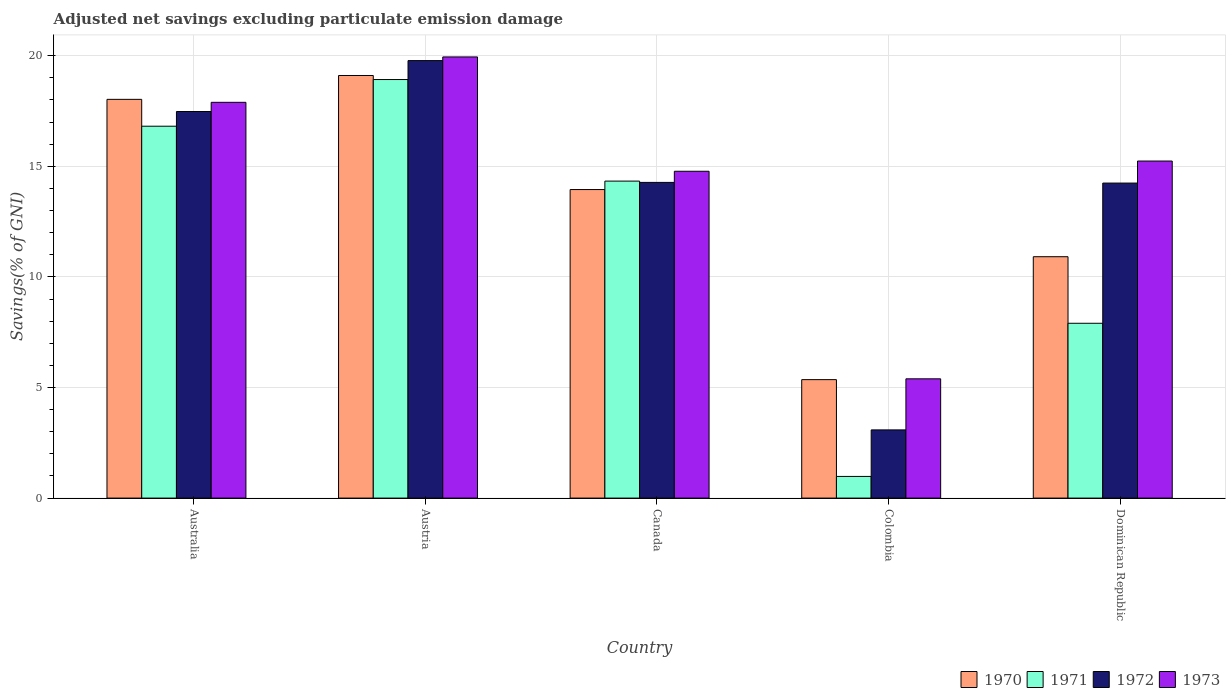How many different coloured bars are there?
Your answer should be compact. 4. How many groups of bars are there?
Give a very brief answer. 5. Are the number of bars on each tick of the X-axis equal?
Ensure brevity in your answer.  Yes. How many bars are there on the 3rd tick from the left?
Make the answer very short. 4. How many bars are there on the 5th tick from the right?
Your answer should be compact. 4. What is the label of the 2nd group of bars from the left?
Provide a succinct answer. Austria. What is the adjusted net savings in 1970 in Australia?
Make the answer very short. 18.03. Across all countries, what is the maximum adjusted net savings in 1973?
Make the answer very short. 19.94. Across all countries, what is the minimum adjusted net savings in 1971?
Offer a very short reply. 0.98. In which country was the adjusted net savings in 1972 maximum?
Keep it short and to the point. Austria. In which country was the adjusted net savings in 1971 minimum?
Keep it short and to the point. Colombia. What is the total adjusted net savings in 1972 in the graph?
Ensure brevity in your answer.  68.85. What is the difference between the adjusted net savings in 1972 in Colombia and that in Dominican Republic?
Provide a succinct answer. -11.16. What is the difference between the adjusted net savings in 1971 in Austria and the adjusted net savings in 1973 in Australia?
Your response must be concise. 1.03. What is the average adjusted net savings in 1972 per country?
Offer a terse response. 13.77. What is the difference between the adjusted net savings of/in 1970 and adjusted net savings of/in 1972 in Canada?
Provide a short and direct response. -0.32. What is the ratio of the adjusted net savings in 1970 in Australia to that in Canada?
Provide a succinct answer. 1.29. Is the adjusted net savings in 1970 in Australia less than that in Canada?
Make the answer very short. No. Is the difference between the adjusted net savings in 1970 in Austria and Colombia greater than the difference between the adjusted net savings in 1972 in Austria and Colombia?
Your answer should be compact. No. What is the difference between the highest and the second highest adjusted net savings in 1972?
Your answer should be very brief. -2.3. What is the difference between the highest and the lowest adjusted net savings in 1971?
Your answer should be very brief. 17.94. How many bars are there?
Your answer should be very brief. 20. Does the graph contain grids?
Make the answer very short. Yes. Where does the legend appear in the graph?
Your response must be concise. Bottom right. How many legend labels are there?
Your answer should be very brief. 4. How are the legend labels stacked?
Ensure brevity in your answer.  Horizontal. What is the title of the graph?
Give a very brief answer. Adjusted net savings excluding particulate emission damage. Does "1961" appear as one of the legend labels in the graph?
Provide a short and direct response. No. What is the label or title of the Y-axis?
Offer a terse response. Savings(% of GNI). What is the Savings(% of GNI) of 1970 in Australia?
Keep it short and to the point. 18.03. What is the Savings(% of GNI) in 1971 in Australia?
Offer a terse response. 16.81. What is the Savings(% of GNI) of 1972 in Australia?
Offer a terse response. 17.48. What is the Savings(% of GNI) in 1973 in Australia?
Give a very brief answer. 17.89. What is the Savings(% of GNI) of 1970 in Austria?
Give a very brief answer. 19.11. What is the Savings(% of GNI) of 1971 in Austria?
Ensure brevity in your answer.  18.92. What is the Savings(% of GNI) in 1972 in Austria?
Offer a terse response. 19.78. What is the Savings(% of GNI) of 1973 in Austria?
Offer a very short reply. 19.94. What is the Savings(% of GNI) in 1970 in Canada?
Offer a terse response. 13.95. What is the Savings(% of GNI) of 1971 in Canada?
Your response must be concise. 14.33. What is the Savings(% of GNI) in 1972 in Canada?
Provide a short and direct response. 14.27. What is the Savings(% of GNI) in 1973 in Canada?
Provide a short and direct response. 14.78. What is the Savings(% of GNI) of 1970 in Colombia?
Make the answer very short. 5.36. What is the Savings(% of GNI) of 1971 in Colombia?
Your answer should be compact. 0.98. What is the Savings(% of GNI) in 1972 in Colombia?
Offer a very short reply. 3.08. What is the Savings(% of GNI) of 1973 in Colombia?
Your answer should be very brief. 5.39. What is the Savings(% of GNI) in 1970 in Dominican Republic?
Offer a very short reply. 10.91. What is the Savings(% of GNI) of 1971 in Dominican Republic?
Your answer should be very brief. 7.9. What is the Savings(% of GNI) of 1972 in Dominican Republic?
Offer a very short reply. 14.24. What is the Savings(% of GNI) of 1973 in Dominican Republic?
Offer a very short reply. 15.24. Across all countries, what is the maximum Savings(% of GNI) of 1970?
Offer a terse response. 19.11. Across all countries, what is the maximum Savings(% of GNI) of 1971?
Offer a terse response. 18.92. Across all countries, what is the maximum Savings(% of GNI) in 1972?
Give a very brief answer. 19.78. Across all countries, what is the maximum Savings(% of GNI) of 1973?
Your answer should be compact. 19.94. Across all countries, what is the minimum Savings(% of GNI) in 1970?
Make the answer very short. 5.36. Across all countries, what is the minimum Savings(% of GNI) in 1971?
Give a very brief answer. 0.98. Across all countries, what is the minimum Savings(% of GNI) of 1972?
Provide a short and direct response. 3.08. Across all countries, what is the minimum Savings(% of GNI) of 1973?
Offer a very short reply. 5.39. What is the total Savings(% of GNI) of 1970 in the graph?
Offer a very short reply. 67.35. What is the total Savings(% of GNI) of 1971 in the graph?
Make the answer very short. 58.95. What is the total Savings(% of GNI) of 1972 in the graph?
Your answer should be compact. 68.85. What is the total Savings(% of GNI) in 1973 in the graph?
Provide a succinct answer. 73.24. What is the difference between the Savings(% of GNI) in 1970 in Australia and that in Austria?
Keep it short and to the point. -1.08. What is the difference between the Savings(% of GNI) of 1971 in Australia and that in Austria?
Provide a short and direct response. -2.11. What is the difference between the Savings(% of GNI) of 1972 in Australia and that in Austria?
Offer a terse response. -2.3. What is the difference between the Savings(% of GNI) of 1973 in Australia and that in Austria?
Your answer should be very brief. -2.05. What is the difference between the Savings(% of GNI) of 1970 in Australia and that in Canada?
Offer a terse response. 4.08. What is the difference between the Savings(% of GNI) in 1971 in Australia and that in Canada?
Provide a succinct answer. 2.48. What is the difference between the Savings(% of GNI) of 1972 in Australia and that in Canada?
Offer a terse response. 3.2. What is the difference between the Savings(% of GNI) in 1973 in Australia and that in Canada?
Offer a very short reply. 3.12. What is the difference between the Savings(% of GNI) of 1970 in Australia and that in Colombia?
Your response must be concise. 12.67. What is the difference between the Savings(% of GNI) in 1971 in Australia and that in Colombia?
Give a very brief answer. 15.83. What is the difference between the Savings(% of GNI) of 1972 in Australia and that in Colombia?
Your answer should be compact. 14.39. What is the difference between the Savings(% of GNI) of 1973 in Australia and that in Colombia?
Make the answer very short. 12.5. What is the difference between the Savings(% of GNI) of 1970 in Australia and that in Dominican Republic?
Your answer should be compact. 7.11. What is the difference between the Savings(% of GNI) of 1971 in Australia and that in Dominican Republic?
Your answer should be very brief. 8.91. What is the difference between the Savings(% of GNI) of 1972 in Australia and that in Dominican Republic?
Offer a terse response. 3.23. What is the difference between the Savings(% of GNI) in 1973 in Australia and that in Dominican Republic?
Your answer should be compact. 2.65. What is the difference between the Savings(% of GNI) in 1970 in Austria and that in Canada?
Ensure brevity in your answer.  5.16. What is the difference between the Savings(% of GNI) in 1971 in Austria and that in Canada?
Your answer should be compact. 4.59. What is the difference between the Savings(% of GNI) of 1972 in Austria and that in Canada?
Ensure brevity in your answer.  5.51. What is the difference between the Savings(% of GNI) in 1973 in Austria and that in Canada?
Your answer should be very brief. 5.17. What is the difference between the Savings(% of GNI) in 1970 in Austria and that in Colombia?
Ensure brevity in your answer.  13.75. What is the difference between the Savings(% of GNI) of 1971 in Austria and that in Colombia?
Provide a short and direct response. 17.94. What is the difference between the Savings(% of GNI) of 1972 in Austria and that in Colombia?
Make the answer very short. 16.7. What is the difference between the Savings(% of GNI) in 1973 in Austria and that in Colombia?
Ensure brevity in your answer.  14.55. What is the difference between the Savings(% of GNI) in 1970 in Austria and that in Dominican Republic?
Your answer should be very brief. 8.19. What is the difference between the Savings(% of GNI) in 1971 in Austria and that in Dominican Republic?
Provide a succinct answer. 11.02. What is the difference between the Savings(% of GNI) in 1972 in Austria and that in Dominican Republic?
Your answer should be very brief. 5.54. What is the difference between the Savings(% of GNI) of 1973 in Austria and that in Dominican Republic?
Offer a terse response. 4.71. What is the difference between the Savings(% of GNI) in 1970 in Canada and that in Colombia?
Your response must be concise. 8.59. What is the difference between the Savings(% of GNI) of 1971 in Canada and that in Colombia?
Offer a terse response. 13.35. What is the difference between the Savings(% of GNI) of 1972 in Canada and that in Colombia?
Provide a short and direct response. 11.19. What is the difference between the Savings(% of GNI) of 1973 in Canada and that in Colombia?
Provide a short and direct response. 9.38. What is the difference between the Savings(% of GNI) in 1970 in Canada and that in Dominican Republic?
Offer a terse response. 3.04. What is the difference between the Savings(% of GNI) in 1971 in Canada and that in Dominican Republic?
Keep it short and to the point. 6.43. What is the difference between the Savings(% of GNI) in 1972 in Canada and that in Dominican Republic?
Offer a very short reply. 0.03. What is the difference between the Savings(% of GNI) of 1973 in Canada and that in Dominican Republic?
Keep it short and to the point. -0.46. What is the difference between the Savings(% of GNI) in 1970 in Colombia and that in Dominican Republic?
Keep it short and to the point. -5.56. What is the difference between the Savings(% of GNI) in 1971 in Colombia and that in Dominican Republic?
Your response must be concise. -6.92. What is the difference between the Savings(% of GNI) of 1972 in Colombia and that in Dominican Republic?
Your answer should be compact. -11.16. What is the difference between the Savings(% of GNI) in 1973 in Colombia and that in Dominican Republic?
Provide a succinct answer. -9.85. What is the difference between the Savings(% of GNI) in 1970 in Australia and the Savings(% of GNI) in 1971 in Austria?
Offer a terse response. -0.9. What is the difference between the Savings(% of GNI) in 1970 in Australia and the Savings(% of GNI) in 1972 in Austria?
Ensure brevity in your answer.  -1.75. What is the difference between the Savings(% of GNI) of 1970 in Australia and the Savings(% of GNI) of 1973 in Austria?
Keep it short and to the point. -1.92. What is the difference between the Savings(% of GNI) of 1971 in Australia and the Savings(% of GNI) of 1972 in Austria?
Your response must be concise. -2.97. What is the difference between the Savings(% of GNI) in 1971 in Australia and the Savings(% of GNI) in 1973 in Austria?
Ensure brevity in your answer.  -3.13. What is the difference between the Savings(% of GNI) of 1972 in Australia and the Savings(% of GNI) of 1973 in Austria?
Keep it short and to the point. -2.47. What is the difference between the Savings(% of GNI) of 1970 in Australia and the Savings(% of GNI) of 1971 in Canada?
Your response must be concise. 3.7. What is the difference between the Savings(% of GNI) in 1970 in Australia and the Savings(% of GNI) in 1972 in Canada?
Keep it short and to the point. 3.75. What is the difference between the Savings(% of GNI) in 1970 in Australia and the Savings(% of GNI) in 1973 in Canada?
Offer a very short reply. 3.25. What is the difference between the Savings(% of GNI) in 1971 in Australia and the Savings(% of GNI) in 1972 in Canada?
Your answer should be very brief. 2.54. What is the difference between the Savings(% of GNI) in 1971 in Australia and the Savings(% of GNI) in 1973 in Canada?
Your response must be concise. 2.04. What is the difference between the Savings(% of GNI) of 1970 in Australia and the Savings(% of GNI) of 1971 in Colombia?
Ensure brevity in your answer.  17.05. What is the difference between the Savings(% of GNI) of 1970 in Australia and the Savings(% of GNI) of 1972 in Colombia?
Give a very brief answer. 14.94. What is the difference between the Savings(% of GNI) of 1970 in Australia and the Savings(% of GNI) of 1973 in Colombia?
Offer a terse response. 12.63. What is the difference between the Savings(% of GNI) in 1971 in Australia and the Savings(% of GNI) in 1972 in Colombia?
Make the answer very short. 13.73. What is the difference between the Savings(% of GNI) of 1971 in Australia and the Savings(% of GNI) of 1973 in Colombia?
Your answer should be very brief. 11.42. What is the difference between the Savings(% of GNI) of 1972 in Australia and the Savings(% of GNI) of 1973 in Colombia?
Ensure brevity in your answer.  12.08. What is the difference between the Savings(% of GNI) of 1970 in Australia and the Savings(% of GNI) of 1971 in Dominican Republic?
Give a very brief answer. 10.12. What is the difference between the Savings(% of GNI) in 1970 in Australia and the Savings(% of GNI) in 1972 in Dominican Republic?
Offer a very short reply. 3.78. What is the difference between the Savings(% of GNI) of 1970 in Australia and the Savings(% of GNI) of 1973 in Dominican Republic?
Provide a short and direct response. 2.79. What is the difference between the Savings(% of GNI) in 1971 in Australia and the Savings(% of GNI) in 1972 in Dominican Republic?
Offer a terse response. 2.57. What is the difference between the Savings(% of GNI) of 1971 in Australia and the Savings(% of GNI) of 1973 in Dominican Republic?
Ensure brevity in your answer.  1.57. What is the difference between the Savings(% of GNI) in 1972 in Australia and the Savings(% of GNI) in 1973 in Dominican Republic?
Give a very brief answer. 2.24. What is the difference between the Savings(% of GNI) in 1970 in Austria and the Savings(% of GNI) in 1971 in Canada?
Offer a terse response. 4.77. What is the difference between the Savings(% of GNI) of 1970 in Austria and the Savings(% of GNI) of 1972 in Canada?
Offer a very short reply. 4.83. What is the difference between the Savings(% of GNI) of 1970 in Austria and the Savings(% of GNI) of 1973 in Canada?
Provide a short and direct response. 4.33. What is the difference between the Savings(% of GNI) in 1971 in Austria and the Savings(% of GNI) in 1972 in Canada?
Provide a succinct answer. 4.65. What is the difference between the Savings(% of GNI) in 1971 in Austria and the Savings(% of GNI) in 1973 in Canada?
Ensure brevity in your answer.  4.15. What is the difference between the Savings(% of GNI) in 1972 in Austria and the Savings(% of GNI) in 1973 in Canada?
Your answer should be very brief. 5. What is the difference between the Savings(% of GNI) in 1970 in Austria and the Savings(% of GNI) in 1971 in Colombia?
Provide a succinct answer. 18.13. What is the difference between the Savings(% of GNI) of 1970 in Austria and the Savings(% of GNI) of 1972 in Colombia?
Keep it short and to the point. 16.02. What is the difference between the Savings(% of GNI) in 1970 in Austria and the Savings(% of GNI) in 1973 in Colombia?
Provide a short and direct response. 13.71. What is the difference between the Savings(% of GNI) of 1971 in Austria and the Savings(% of GNI) of 1972 in Colombia?
Ensure brevity in your answer.  15.84. What is the difference between the Savings(% of GNI) of 1971 in Austria and the Savings(% of GNI) of 1973 in Colombia?
Keep it short and to the point. 13.53. What is the difference between the Savings(% of GNI) of 1972 in Austria and the Savings(% of GNI) of 1973 in Colombia?
Keep it short and to the point. 14.39. What is the difference between the Savings(% of GNI) of 1970 in Austria and the Savings(% of GNI) of 1971 in Dominican Republic?
Your response must be concise. 11.2. What is the difference between the Savings(% of GNI) of 1970 in Austria and the Savings(% of GNI) of 1972 in Dominican Republic?
Your response must be concise. 4.86. What is the difference between the Savings(% of GNI) of 1970 in Austria and the Savings(% of GNI) of 1973 in Dominican Republic?
Your answer should be very brief. 3.87. What is the difference between the Savings(% of GNI) of 1971 in Austria and the Savings(% of GNI) of 1972 in Dominican Republic?
Provide a succinct answer. 4.68. What is the difference between the Savings(% of GNI) in 1971 in Austria and the Savings(% of GNI) in 1973 in Dominican Republic?
Your answer should be compact. 3.68. What is the difference between the Savings(% of GNI) in 1972 in Austria and the Savings(% of GNI) in 1973 in Dominican Republic?
Give a very brief answer. 4.54. What is the difference between the Savings(% of GNI) of 1970 in Canada and the Savings(% of GNI) of 1971 in Colombia?
Offer a terse response. 12.97. What is the difference between the Savings(% of GNI) in 1970 in Canada and the Savings(% of GNI) in 1972 in Colombia?
Provide a short and direct response. 10.87. What is the difference between the Savings(% of GNI) in 1970 in Canada and the Savings(% of GNI) in 1973 in Colombia?
Make the answer very short. 8.56. What is the difference between the Savings(% of GNI) in 1971 in Canada and the Savings(% of GNI) in 1972 in Colombia?
Offer a very short reply. 11.25. What is the difference between the Savings(% of GNI) of 1971 in Canada and the Savings(% of GNI) of 1973 in Colombia?
Provide a short and direct response. 8.94. What is the difference between the Savings(% of GNI) of 1972 in Canada and the Savings(% of GNI) of 1973 in Colombia?
Provide a succinct answer. 8.88. What is the difference between the Savings(% of GNI) in 1970 in Canada and the Savings(% of GNI) in 1971 in Dominican Republic?
Give a very brief answer. 6.05. What is the difference between the Savings(% of GNI) of 1970 in Canada and the Savings(% of GNI) of 1972 in Dominican Republic?
Provide a short and direct response. -0.29. What is the difference between the Savings(% of GNI) in 1970 in Canada and the Savings(% of GNI) in 1973 in Dominican Republic?
Your answer should be compact. -1.29. What is the difference between the Savings(% of GNI) in 1971 in Canada and the Savings(% of GNI) in 1972 in Dominican Republic?
Make the answer very short. 0.09. What is the difference between the Savings(% of GNI) in 1971 in Canada and the Savings(% of GNI) in 1973 in Dominican Republic?
Ensure brevity in your answer.  -0.91. What is the difference between the Savings(% of GNI) of 1972 in Canada and the Savings(% of GNI) of 1973 in Dominican Republic?
Your response must be concise. -0.97. What is the difference between the Savings(% of GNI) in 1970 in Colombia and the Savings(% of GNI) in 1971 in Dominican Republic?
Provide a succinct answer. -2.55. What is the difference between the Savings(% of GNI) in 1970 in Colombia and the Savings(% of GNI) in 1972 in Dominican Republic?
Your answer should be compact. -8.89. What is the difference between the Savings(% of GNI) of 1970 in Colombia and the Savings(% of GNI) of 1973 in Dominican Republic?
Keep it short and to the point. -9.88. What is the difference between the Savings(% of GNI) of 1971 in Colombia and the Savings(% of GNI) of 1972 in Dominican Republic?
Ensure brevity in your answer.  -13.26. What is the difference between the Savings(% of GNI) in 1971 in Colombia and the Savings(% of GNI) in 1973 in Dominican Republic?
Offer a very short reply. -14.26. What is the difference between the Savings(% of GNI) of 1972 in Colombia and the Savings(% of GNI) of 1973 in Dominican Republic?
Provide a short and direct response. -12.15. What is the average Savings(% of GNI) of 1970 per country?
Keep it short and to the point. 13.47. What is the average Savings(% of GNI) in 1971 per country?
Give a very brief answer. 11.79. What is the average Savings(% of GNI) in 1972 per country?
Your response must be concise. 13.77. What is the average Savings(% of GNI) of 1973 per country?
Give a very brief answer. 14.65. What is the difference between the Savings(% of GNI) in 1970 and Savings(% of GNI) in 1971 in Australia?
Offer a very short reply. 1.21. What is the difference between the Savings(% of GNI) of 1970 and Savings(% of GNI) of 1972 in Australia?
Your answer should be compact. 0.55. What is the difference between the Savings(% of GNI) of 1970 and Savings(% of GNI) of 1973 in Australia?
Give a very brief answer. 0.13. What is the difference between the Savings(% of GNI) in 1971 and Savings(% of GNI) in 1972 in Australia?
Provide a short and direct response. -0.66. What is the difference between the Savings(% of GNI) in 1971 and Savings(% of GNI) in 1973 in Australia?
Ensure brevity in your answer.  -1.08. What is the difference between the Savings(% of GNI) of 1972 and Savings(% of GNI) of 1973 in Australia?
Your response must be concise. -0.42. What is the difference between the Savings(% of GNI) in 1970 and Savings(% of GNI) in 1971 in Austria?
Your answer should be very brief. 0.18. What is the difference between the Savings(% of GNI) of 1970 and Savings(% of GNI) of 1972 in Austria?
Offer a very short reply. -0.67. What is the difference between the Savings(% of GNI) of 1970 and Savings(% of GNI) of 1973 in Austria?
Provide a short and direct response. -0.84. What is the difference between the Savings(% of GNI) in 1971 and Savings(% of GNI) in 1972 in Austria?
Your answer should be very brief. -0.86. What is the difference between the Savings(% of GNI) in 1971 and Savings(% of GNI) in 1973 in Austria?
Keep it short and to the point. -1.02. What is the difference between the Savings(% of GNI) in 1972 and Savings(% of GNI) in 1973 in Austria?
Your answer should be very brief. -0.17. What is the difference between the Savings(% of GNI) in 1970 and Savings(% of GNI) in 1971 in Canada?
Offer a terse response. -0.38. What is the difference between the Savings(% of GNI) of 1970 and Savings(% of GNI) of 1972 in Canada?
Offer a very short reply. -0.32. What is the difference between the Savings(% of GNI) in 1970 and Savings(% of GNI) in 1973 in Canada?
Your answer should be very brief. -0.83. What is the difference between the Savings(% of GNI) of 1971 and Savings(% of GNI) of 1972 in Canada?
Keep it short and to the point. 0.06. What is the difference between the Savings(% of GNI) in 1971 and Savings(% of GNI) in 1973 in Canada?
Make the answer very short. -0.45. What is the difference between the Savings(% of GNI) in 1972 and Savings(% of GNI) in 1973 in Canada?
Offer a terse response. -0.5. What is the difference between the Savings(% of GNI) in 1970 and Savings(% of GNI) in 1971 in Colombia?
Make the answer very short. 4.38. What is the difference between the Savings(% of GNI) of 1970 and Savings(% of GNI) of 1972 in Colombia?
Provide a succinct answer. 2.27. What is the difference between the Savings(% of GNI) of 1970 and Savings(% of GNI) of 1973 in Colombia?
Offer a very short reply. -0.04. What is the difference between the Savings(% of GNI) in 1971 and Savings(% of GNI) in 1972 in Colombia?
Offer a terse response. -2.1. What is the difference between the Savings(% of GNI) of 1971 and Savings(% of GNI) of 1973 in Colombia?
Keep it short and to the point. -4.41. What is the difference between the Savings(% of GNI) of 1972 and Savings(% of GNI) of 1973 in Colombia?
Provide a short and direct response. -2.31. What is the difference between the Savings(% of GNI) in 1970 and Savings(% of GNI) in 1971 in Dominican Republic?
Keep it short and to the point. 3.01. What is the difference between the Savings(% of GNI) in 1970 and Savings(% of GNI) in 1972 in Dominican Republic?
Make the answer very short. -3.33. What is the difference between the Savings(% of GNI) in 1970 and Savings(% of GNI) in 1973 in Dominican Republic?
Provide a short and direct response. -4.33. What is the difference between the Savings(% of GNI) in 1971 and Savings(% of GNI) in 1972 in Dominican Republic?
Keep it short and to the point. -6.34. What is the difference between the Savings(% of GNI) of 1971 and Savings(% of GNI) of 1973 in Dominican Republic?
Provide a short and direct response. -7.33. What is the difference between the Savings(% of GNI) in 1972 and Savings(% of GNI) in 1973 in Dominican Republic?
Ensure brevity in your answer.  -1. What is the ratio of the Savings(% of GNI) in 1970 in Australia to that in Austria?
Offer a terse response. 0.94. What is the ratio of the Savings(% of GNI) of 1971 in Australia to that in Austria?
Make the answer very short. 0.89. What is the ratio of the Savings(% of GNI) of 1972 in Australia to that in Austria?
Your answer should be compact. 0.88. What is the ratio of the Savings(% of GNI) in 1973 in Australia to that in Austria?
Offer a very short reply. 0.9. What is the ratio of the Savings(% of GNI) of 1970 in Australia to that in Canada?
Keep it short and to the point. 1.29. What is the ratio of the Savings(% of GNI) of 1971 in Australia to that in Canada?
Keep it short and to the point. 1.17. What is the ratio of the Savings(% of GNI) of 1972 in Australia to that in Canada?
Ensure brevity in your answer.  1.22. What is the ratio of the Savings(% of GNI) in 1973 in Australia to that in Canada?
Your response must be concise. 1.21. What is the ratio of the Savings(% of GNI) in 1970 in Australia to that in Colombia?
Your response must be concise. 3.37. What is the ratio of the Savings(% of GNI) in 1971 in Australia to that in Colombia?
Provide a succinct answer. 17.17. What is the ratio of the Savings(% of GNI) in 1972 in Australia to that in Colombia?
Provide a short and direct response. 5.67. What is the ratio of the Savings(% of GNI) of 1973 in Australia to that in Colombia?
Make the answer very short. 3.32. What is the ratio of the Savings(% of GNI) of 1970 in Australia to that in Dominican Republic?
Provide a short and direct response. 1.65. What is the ratio of the Savings(% of GNI) in 1971 in Australia to that in Dominican Republic?
Your answer should be compact. 2.13. What is the ratio of the Savings(% of GNI) in 1972 in Australia to that in Dominican Republic?
Your answer should be compact. 1.23. What is the ratio of the Savings(% of GNI) of 1973 in Australia to that in Dominican Republic?
Give a very brief answer. 1.17. What is the ratio of the Savings(% of GNI) of 1970 in Austria to that in Canada?
Ensure brevity in your answer.  1.37. What is the ratio of the Savings(% of GNI) in 1971 in Austria to that in Canada?
Provide a short and direct response. 1.32. What is the ratio of the Savings(% of GNI) of 1972 in Austria to that in Canada?
Keep it short and to the point. 1.39. What is the ratio of the Savings(% of GNI) in 1973 in Austria to that in Canada?
Offer a terse response. 1.35. What is the ratio of the Savings(% of GNI) of 1970 in Austria to that in Colombia?
Give a very brief answer. 3.57. What is the ratio of the Savings(% of GNI) in 1971 in Austria to that in Colombia?
Your response must be concise. 19.32. What is the ratio of the Savings(% of GNI) of 1972 in Austria to that in Colombia?
Offer a terse response. 6.42. What is the ratio of the Savings(% of GNI) in 1973 in Austria to that in Colombia?
Ensure brevity in your answer.  3.7. What is the ratio of the Savings(% of GNI) in 1970 in Austria to that in Dominican Republic?
Offer a very short reply. 1.75. What is the ratio of the Savings(% of GNI) in 1971 in Austria to that in Dominican Republic?
Make the answer very short. 2.39. What is the ratio of the Savings(% of GNI) of 1972 in Austria to that in Dominican Republic?
Offer a very short reply. 1.39. What is the ratio of the Savings(% of GNI) in 1973 in Austria to that in Dominican Republic?
Your answer should be compact. 1.31. What is the ratio of the Savings(% of GNI) in 1970 in Canada to that in Colombia?
Provide a short and direct response. 2.6. What is the ratio of the Savings(% of GNI) in 1971 in Canada to that in Colombia?
Give a very brief answer. 14.64. What is the ratio of the Savings(% of GNI) of 1972 in Canada to that in Colombia?
Provide a short and direct response. 4.63. What is the ratio of the Savings(% of GNI) in 1973 in Canada to that in Colombia?
Give a very brief answer. 2.74. What is the ratio of the Savings(% of GNI) of 1970 in Canada to that in Dominican Republic?
Provide a succinct answer. 1.28. What is the ratio of the Savings(% of GNI) in 1971 in Canada to that in Dominican Republic?
Provide a succinct answer. 1.81. What is the ratio of the Savings(% of GNI) in 1972 in Canada to that in Dominican Republic?
Ensure brevity in your answer.  1. What is the ratio of the Savings(% of GNI) in 1973 in Canada to that in Dominican Republic?
Offer a terse response. 0.97. What is the ratio of the Savings(% of GNI) of 1970 in Colombia to that in Dominican Republic?
Ensure brevity in your answer.  0.49. What is the ratio of the Savings(% of GNI) of 1971 in Colombia to that in Dominican Republic?
Provide a short and direct response. 0.12. What is the ratio of the Savings(% of GNI) of 1972 in Colombia to that in Dominican Republic?
Your response must be concise. 0.22. What is the ratio of the Savings(% of GNI) of 1973 in Colombia to that in Dominican Republic?
Your answer should be compact. 0.35. What is the difference between the highest and the second highest Savings(% of GNI) in 1970?
Provide a short and direct response. 1.08. What is the difference between the highest and the second highest Savings(% of GNI) of 1971?
Ensure brevity in your answer.  2.11. What is the difference between the highest and the second highest Savings(% of GNI) of 1972?
Provide a succinct answer. 2.3. What is the difference between the highest and the second highest Savings(% of GNI) in 1973?
Provide a succinct answer. 2.05. What is the difference between the highest and the lowest Savings(% of GNI) of 1970?
Your answer should be very brief. 13.75. What is the difference between the highest and the lowest Savings(% of GNI) of 1971?
Your answer should be very brief. 17.94. What is the difference between the highest and the lowest Savings(% of GNI) of 1972?
Provide a short and direct response. 16.7. What is the difference between the highest and the lowest Savings(% of GNI) of 1973?
Make the answer very short. 14.55. 